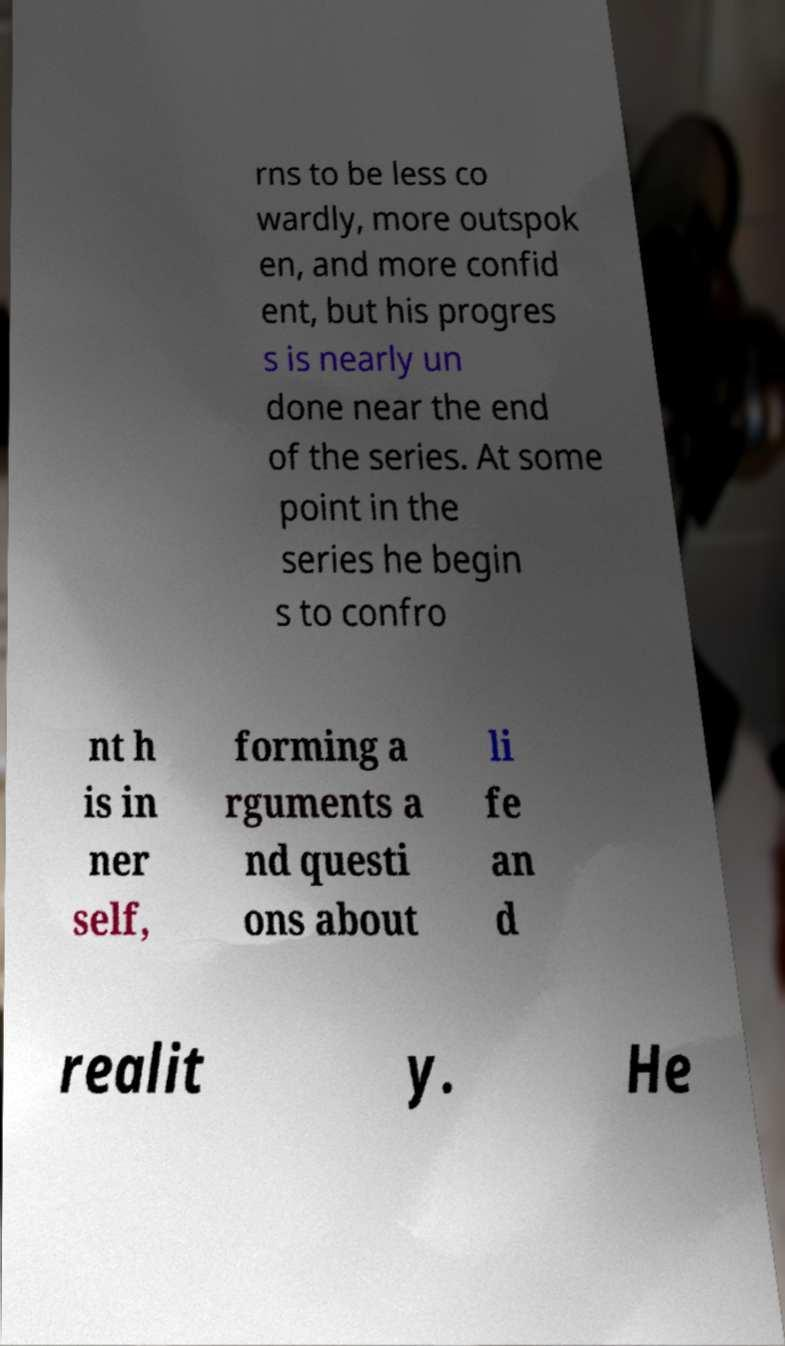There's text embedded in this image that I need extracted. Can you transcribe it verbatim? rns to be less co wardly, more outspok en, and more confid ent, but his progres s is nearly un done near the end of the series. At some point in the series he begin s to confro nt h is in ner self, forming a rguments a nd questi ons about li fe an d realit y. He 